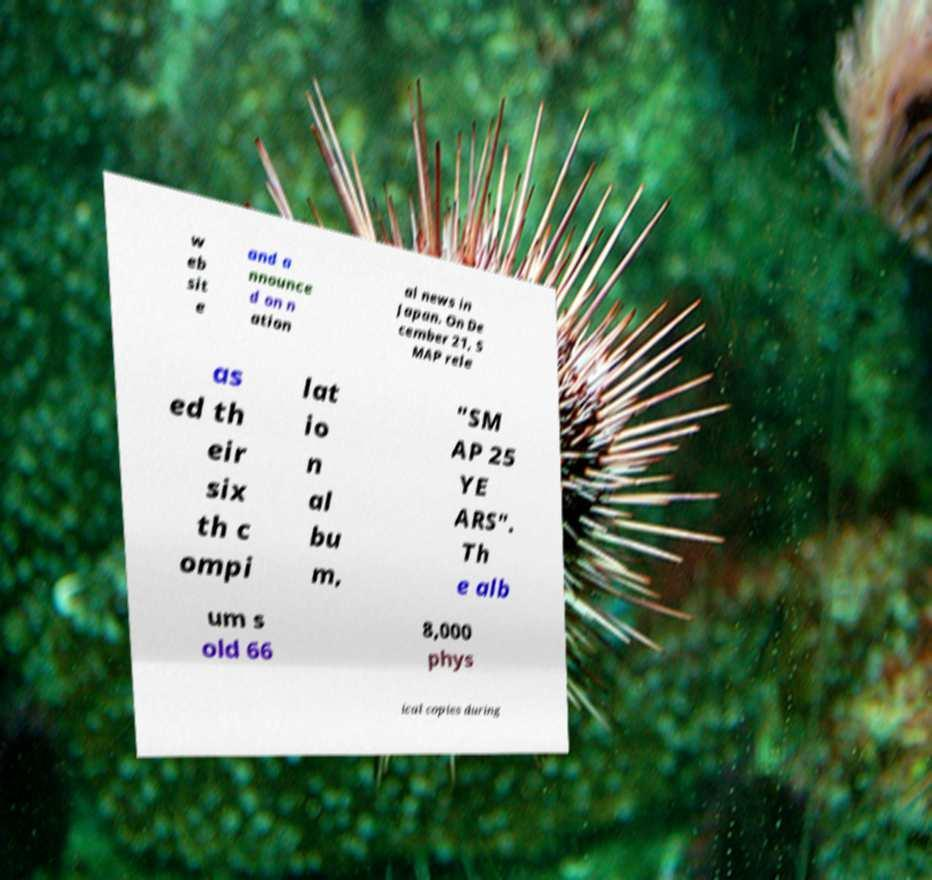Please identify and transcribe the text found in this image. w eb sit e and a nnounce d on n ation al news in Japan. On De cember 21, S MAP rele as ed th eir six th c ompi lat io n al bu m, "SM AP 25 YE ARS". Th e alb um s old 66 8,000 phys ical copies during 